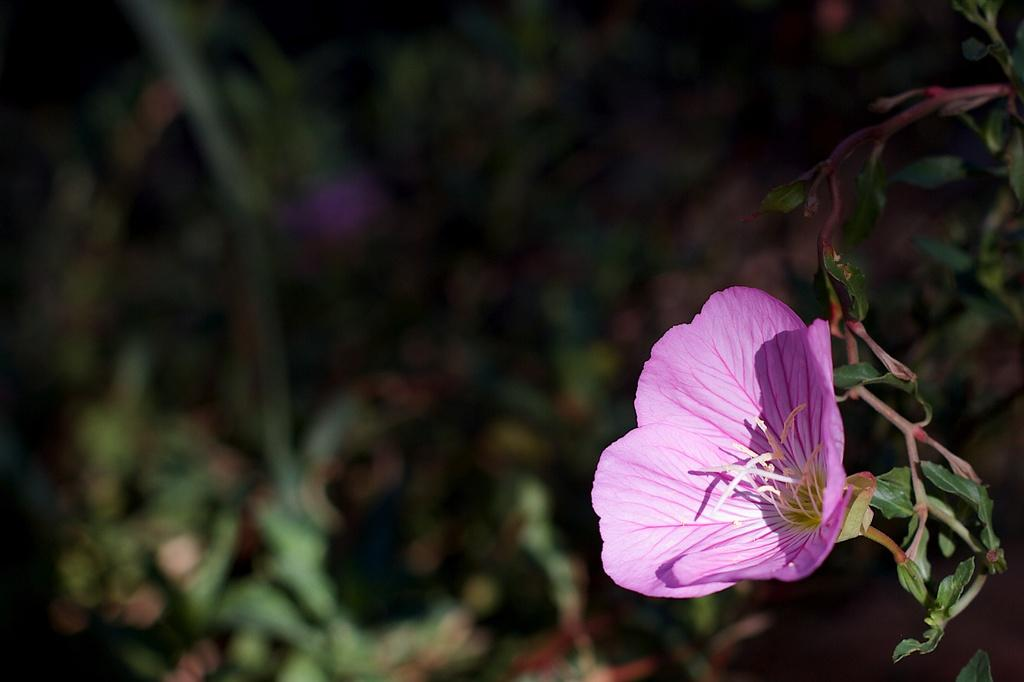What is the main subject of the image? The main subject of the image is a flower. Can you describe the flower's position in the image? The flower is on the stem of a plant. How would you describe the background of the image? The background of the image is blurred. What date is marked on the calendar in the image? There is no calendar present in the image. Can you describe the faucet in the image? There is no faucet present in the image. 